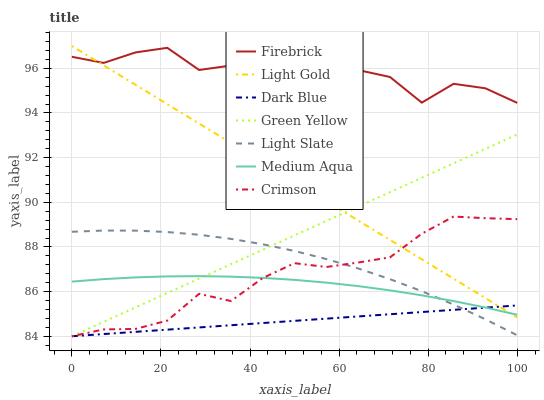Does Dark Blue have the minimum area under the curve?
Answer yes or no. Yes. Does Firebrick have the maximum area under the curve?
Answer yes or no. Yes. Does Firebrick have the minimum area under the curve?
Answer yes or no. No. Does Dark Blue have the maximum area under the curve?
Answer yes or no. No. Is Green Yellow the smoothest?
Answer yes or no. Yes. Is Firebrick the roughest?
Answer yes or no. Yes. Is Dark Blue the smoothest?
Answer yes or no. No. Is Dark Blue the roughest?
Answer yes or no. No. Does Dark Blue have the lowest value?
Answer yes or no. Yes. Does Firebrick have the lowest value?
Answer yes or no. No. Does Light Gold have the highest value?
Answer yes or no. Yes. Does Firebrick have the highest value?
Answer yes or no. No. Is Medium Aqua less than Firebrick?
Answer yes or no. Yes. Is Firebrick greater than Green Yellow?
Answer yes or no. Yes. Does Crimson intersect Light Gold?
Answer yes or no. Yes. Is Crimson less than Light Gold?
Answer yes or no. No. Is Crimson greater than Light Gold?
Answer yes or no. No. Does Medium Aqua intersect Firebrick?
Answer yes or no. No. 